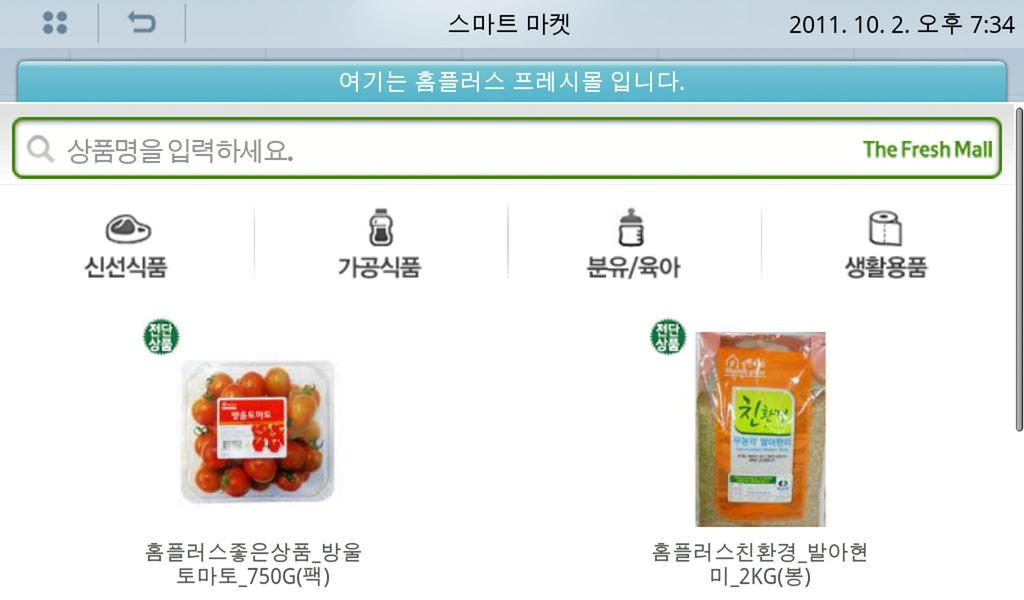What type of image is being described? The image is a screenshot of a website. How many pear-shaped fangs can be seen on the partner in the image? There is no partner or pear-shaped fangs present in the image, as it is a screenshot of a website. 